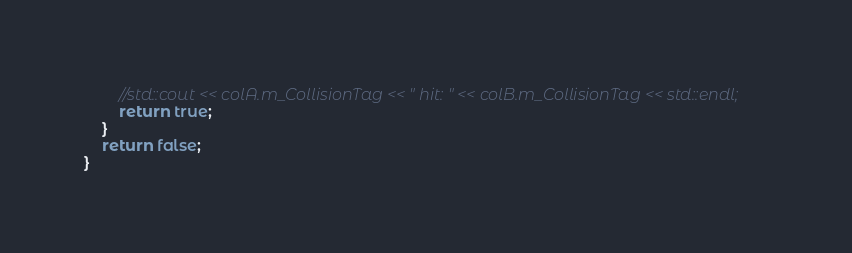Convert code to text. <code><loc_0><loc_0><loc_500><loc_500><_C++_>        //std::cout << colA.m_CollisionTag << " hit: " << colB.m_CollisionTag << std::endl;
        return true;
    }
    return false;
}
</code> 